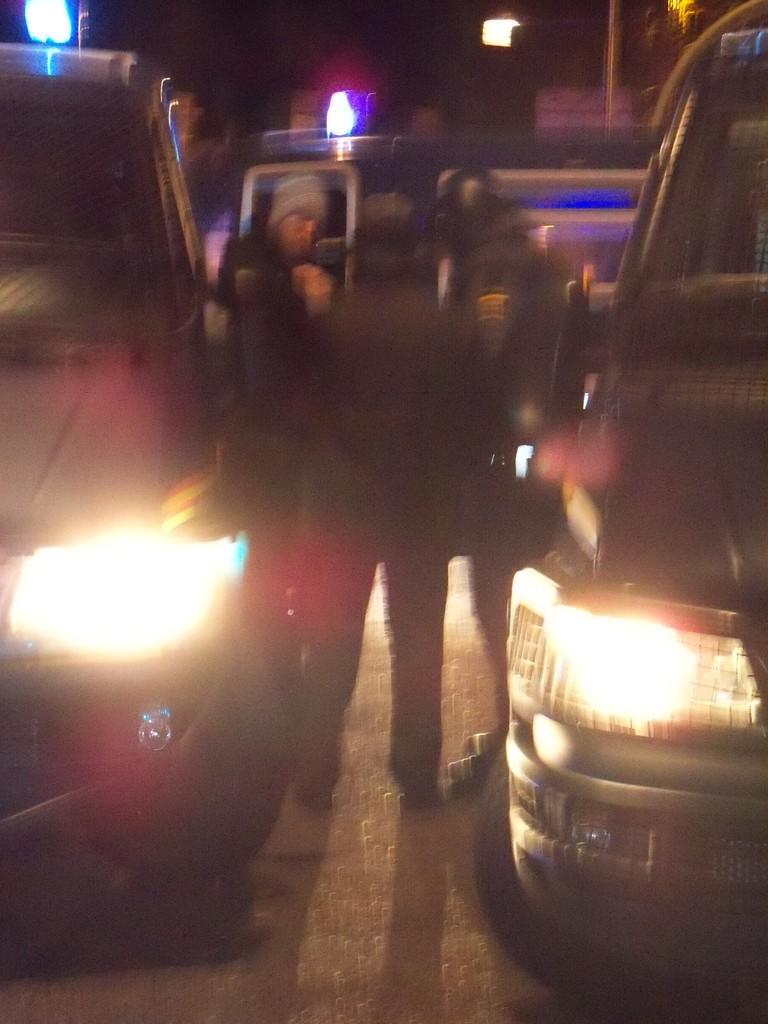How would you summarize this image in a sentence or two? In this image we can see there are few cars and a few people are on the road and there are few street lights. 